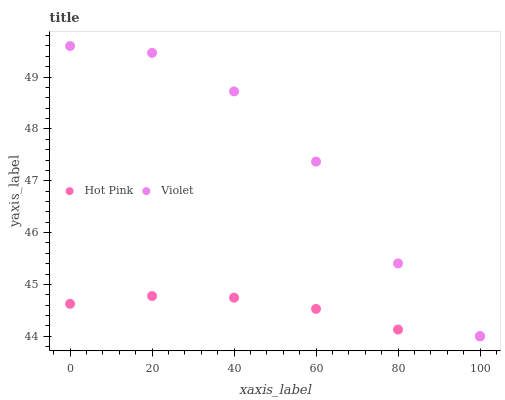Does Hot Pink have the minimum area under the curve?
Answer yes or no. Yes. Does Violet have the maximum area under the curve?
Answer yes or no. Yes. Does Violet have the minimum area under the curve?
Answer yes or no. No. Is Hot Pink the smoothest?
Answer yes or no. Yes. Is Violet the roughest?
Answer yes or no. Yes. Is Violet the smoothest?
Answer yes or no. No. Does Hot Pink have the lowest value?
Answer yes or no. Yes. Does Violet have the highest value?
Answer yes or no. Yes. Does Violet intersect Hot Pink?
Answer yes or no. Yes. Is Violet less than Hot Pink?
Answer yes or no. No. Is Violet greater than Hot Pink?
Answer yes or no. No. 